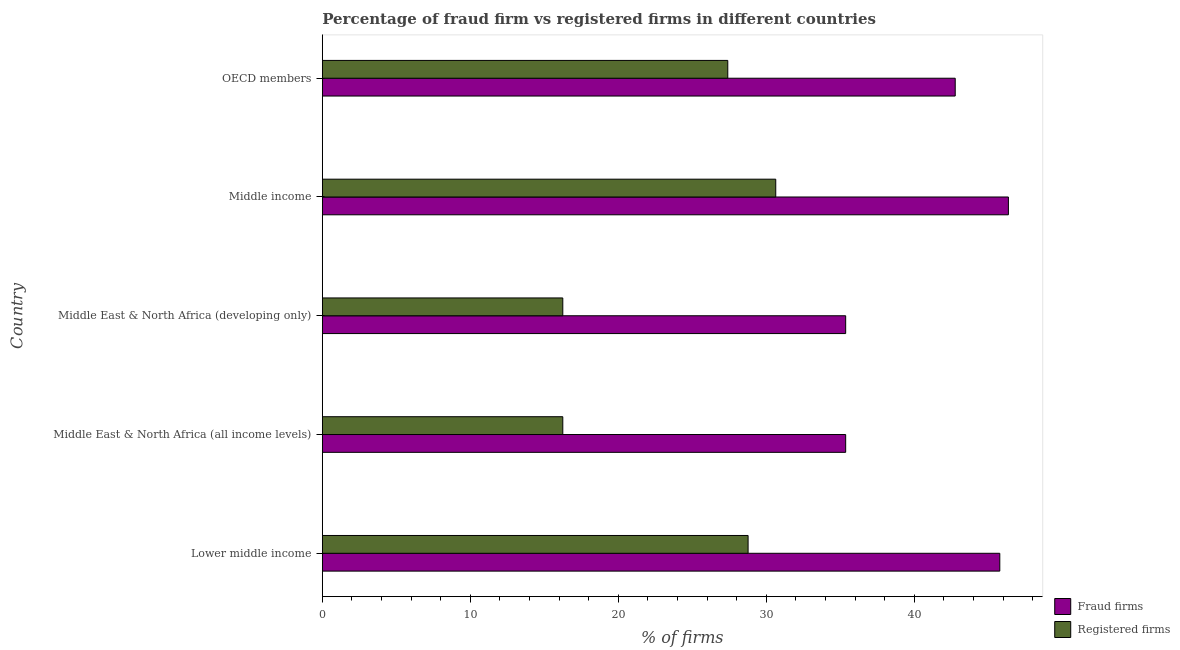How many different coloured bars are there?
Offer a terse response. 2. How many groups of bars are there?
Your answer should be very brief. 5. Are the number of bars per tick equal to the number of legend labels?
Offer a very short reply. Yes. Are the number of bars on each tick of the Y-axis equal?
Your answer should be very brief. Yes. How many bars are there on the 5th tick from the bottom?
Provide a succinct answer. 2. What is the label of the 5th group of bars from the top?
Ensure brevity in your answer.  Lower middle income. What is the percentage of registered firms in Middle income?
Ensure brevity in your answer.  30.64. Across all countries, what is the maximum percentage of registered firms?
Your answer should be compact. 30.64. Across all countries, what is the minimum percentage of fraud firms?
Your answer should be compact. 35.37. In which country was the percentage of registered firms minimum?
Make the answer very short. Middle East & North Africa (all income levels). What is the total percentage of fraud firms in the graph?
Give a very brief answer. 205.65. What is the difference between the percentage of fraud firms in Middle East & North Africa (all income levels) and that in OECD members?
Offer a terse response. -7.4. What is the difference between the percentage of registered firms in OECD members and the percentage of fraud firms in Middle East & North Africa (developing only)?
Ensure brevity in your answer.  -7.97. What is the average percentage of fraud firms per country?
Offer a terse response. 41.13. What is the difference between the percentage of fraud firms and percentage of registered firms in Middle East & North Africa (all income levels)?
Make the answer very short. 19.12. In how many countries, is the percentage of registered firms greater than 42 %?
Provide a succinct answer. 0. What is the ratio of the percentage of registered firms in Middle East & North Africa (all income levels) to that in Middle income?
Provide a succinct answer. 0.53. Is the percentage of fraud firms in Middle East & North Africa (developing only) less than that in OECD members?
Your response must be concise. Yes. Is the difference between the percentage of registered firms in Middle East & North Africa (developing only) and Middle income greater than the difference between the percentage of fraud firms in Middle East & North Africa (developing only) and Middle income?
Keep it short and to the point. No. What is the difference between the highest and the second highest percentage of registered firms?
Provide a short and direct response. 1.87. What is the difference between the highest and the lowest percentage of fraud firms?
Your answer should be very brief. 11. In how many countries, is the percentage of fraud firms greater than the average percentage of fraud firms taken over all countries?
Your response must be concise. 3. What does the 2nd bar from the top in Middle East & North Africa (all income levels) represents?
Make the answer very short. Fraud firms. What does the 2nd bar from the bottom in Middle income represents?
Make the answer very short. Registered firms. Are all the bars in the graph horizontal?
Your answer should be very brief. Yes. How many countries are there in the graph?
Your response must be concise. 5. Are the values on the major ticks of X-axis written in scientific E-notation?
Make the answer very short. No. Does the graph contain grids?
Your answer should be very brief. No. Where does the legend appear in the graph?
Your answer should be very brief. Bottom right. What is the title of the graph?
Offer a terse response. Percentage of fraud firm vs registered firms in different countries. What is the label or title of the X-axis?
Offer a very short reply. % of firms. What is the label or title of the Y-axis?
Your response must be concise. Country. What is the % of firms in Fraud firms in Lower middle income?
Your answer should be very brief. 45.78. What is the % of firms in Registered firms in Lower middle income?
Give a very brief answer. 28.77. What is the % of firms in Fraud firms in Middle East & North Africa (all income levels)?
Provide a short and direct response. 35.37. What is the % of firms of Registered firms in Middle East & North Africa (all income levels)?
Keep it short and to the point. 16.25. What is the % of firms in Fraud firms in Middle East & North Africa (developing only)?
Provide a succinct answer. 35.37. What is the % of firms of Registered firms in Middle East & North Africa (developing only)?
Offer a terse response. 16.25. What is the % of firms in Fraud firms in Middle income?
Provide a succinct answer. 46.36. What is the % of firms of Registered firms in Middle income?
Ensure brevity in your answer.  30.64. What is the % of firms in Fraud firms in OECD members?
Give a very brief answer. 42.77. What is the % of firms of Registered firms in OECD members?
Offer a very short reply. 27.4. Across all countries, what is the maximum % of firms of Fraud firms?
Give a very brief answer. 46.36. Across all countries, what is the maximum % of firms in Registered firms?
Offer a very short reply. 30.64. Across all countries, what is the minimum % of firms in Fraud firms?
Your answer should be compact. 35.37. Across all countries, what is the minimum % of firms of Registered firms?
Your response must be concise. 16.25. What is the total % of firms in Fraud firms in the graph?
Offer a very short reply. 205.65. What is the total % of firms of Registered firms in the graph?
Keep it short and to the point. 119.31. What is the difference between the % of firms in Fraud firms in Lower middle income and that in Middle East & North Africa (all income levels)?
Offer a very short reply. 10.42. What is the difference between the % of firms of Registered firms in Lower middle income and that in Middle East & North Africa (all income levels)?
Give a very brief answer. 12.52. What is the difference between the % of firms in Fraud firms in Lower middle income and that in Middle East & North Africa (developing only)?
Your response must be concise. 10.42. What is the difference between the % of firms in Registered firms in Lower middle income and that in Middle East & North Africa (developing only)?
Provide a short and direct response. 12.52. What is the difference between the % of firms in Fraud firms in Lower middle income and that in Middle income?
Ensure brevity in your answer.  -0.58. What is the difference between the % of firms of Registered firms in Lower middle income and that in Middle income?
Offer a very short reply. -1.87. What is the difference between the % of firms of Fraud firms in Lower middle income and that in OECD members?
Give a very brief answer. 3.01. What is the difference between the % of firms of Registered firms in Lower middle income and that in OECD members?
Your answer should be compact. 1.37. What is the difference between the % of firms in Registered firms in Middle East & North Africa (all income levels) and that in Middle East & North Africa (developing only)?
Your answer should be compact. 0. What is the difference between the % of firms in Fraud firms in Middle East & North Africa (all income levels) and that in Middle income?
Your answer should be compact. -11. What is the difference between the % of firms of Registered firms in Middle East & North Africa (all income levels) and that in Middle income?
Make the answer very short. -14.39. What is the difference between the % of firms of Fraud firms in Middle East & North Africa (all income levels) and that in OECD members?
Make the answer very short. -7.4. What is the difference between the % of firms in Registered firms in Middle East & North Africa (all income levels) and that in OECD members?
Keep it short and to the point. -11.15. What is the difference between the % of firms of Fraud firms in Middle East & North Africa (developing only) and that in Middle income?
Your response must be concise. -11. What is the difference between the % of firms in Registered firms in Middle East & North Africa (developing only) and that in Middle income?
Keep it short and to the point. -14.39. What is the difference between the % of firms in Fraud firms in Middle East & North Africa (developing only) and that in OECD members?
Offer a very short reply. -7.4. What is the difference between the % of firms in Registered firms in Middle East & North Africa (developing only) and that in OECD members?
Your answer should be very brief. -11.15. What is the difference between the % of firms of Fraud firms in Middle income and that in OECD members?
Give a very brief answer. 3.59. What is the difference between the % of firms of Registered firms in Middle income and that in OECD members?
Your answer should be very brief. 3.24. What is the difference between the % of firms in Fraud firms in Lower middle income and the % of firms in Registered firms in Middle East & North Africa (all income levels)?
Ensure brevity in your answer.  29.53. What is the difference between the % of firms of Fraud firms in Lower middle income and the % of firms of Registered firms in Middle East & North Africa (developing only)?
Your answer should be very brief. 29.53. What is the difference between the % of firms in Fraud firms in Lower middle income and the % of firms in Registered firms in Middle income?
Keep it short and to the point. 15.14. What is the difference between the % of firms of Fraud firms in Lower middle income and the % of firms of Registered firms in OECD members?
Provide a succinct answer. 18.38. What is the difference between the % of firms of Fraud firms in Middle East & North Africa (all income levels) and the % of firms of Registered firms in Middle East & North Africa (developing only)?
Your response must be concise. 19.12. What is the difference between the % of firms of Fraud firms in Middle East & North Africa (all income levels) and the % of firms of Registered firms in Middle income?
Provide a short and direct response. 4.73. What is the difference between the % of firms in Fraud firms in Middle East & North Africa (all income levels) and the % of firms in Registered firms in OECD members?
Give a very brief answer. 7.97. What is the difference between the % of firms of Fraud firms in Middle East & North Africa (developing only) and the % of firms of Registered firms in Middle income?
Offer a terse response. 4.73. What is the difference between the % of firms in Fraud firms in Middle East & North Africa (developing only) and the % of firms in Registered firms in OECD members?
Ensure brevity in your answer.  7.97. What is the difference between the % of firms in Fraud firms in Middle income and the % of firms in Registered firms in OECD members?
Keep it short and to the point. 18.96. What is the average % of firms of Fraud firms per country?
Keep it short and to the point. 41.13. What is the average % of firms in Registered firms per country?
Make the answer very short. 23.86. What is the difference between the % of firms in Fraud firms and % of firms in Registered firms in Lower middle income?
Your answer should be very brief. 17.01. What is the difference between the % of firms of Fraud firms and % of firms of Registered firms in Middle East & North Africa (all income levels)?
Provide a succinct answer. 19.12. What is the difference between the % of firms of Fraud firms and % of firms of Registered firms in Middle East & North Africa (developing only)?
Your response must be concise. 19.12. What is the difference between the % of firms of Fraud firms and % of firms of Registered firms in Middle income?
Your answer should be compact. 15.72. What is the difference between the % of firms in Fraud firms and % of firms in Registered firms in OECD members?
Keep it short and to the point. 15.37. What is the ratio of the % of firms in Fraud firms in Lower middle income to that in Middle East & North Africa (all income levels)?
Provide a short and direct response. 1.29. What is the ratio of the % of firms in Registered firms in Lower middle income to that in Middle East & North Africa (all income levels)?
Make the answer very short. 1.77. What is the ratio of the % of firms of Fraud firms in Lower middle income to that in Middle East & North Africa (developing only)?
Your answer should be compact. 1.29. What is the ratio of the % of firms of Registered firms in Lower middle income to that in Middle East & North Africa (developing only)?
Keep it short and to the point. 1.77. What is the ratio of the % of firms in Fraud firms in Lower middle income to that in Middle income?
Provide a succinct answer. 0.99. What is the ratio of the % of firms of Registered firms in Lower middle income to that in Middle income?
Ensure brevity in your answer.  0.94. What is the ratio of the % of firms of Fraud firms in Lower middle income to that in OECD members?
Your answer should be very brief. 1.07. What is the ratio of the % of firms in Registered firms in Lower middle income to that in OECD members?
Your answer should be compact. 1.05. What is the ratio of the % of firms of Fraud firms in Middle East & North Africa (all income levels) to that in Middle income?
Make the answer very short. 0.76. What is the ratio of the % of firms of Registered firms in Middle East & North Africa (all income levels) to that in Middle income?
Give a very brief answer. 0.53. What is the ratio of the % of firms of Fraud firms in Middle East & North Africa (all income levels) to that in OECD members?
Ensure brevity in your answer.  0.83. What is the ratio of the % of firms in Registered firms in Middle East & North Africa (all income levels) to that in OECD members?
Give a very brief answer. 0.59. What is the ratio of the % of firms of Fraud firms in Middle East & North Africa (developing only) to that in Middle income?
Ensure brevity in your answer.  0.76. What is the ratio of the % of firms in Registered firms in Middle East & North Africa (developing only) to that in Middle income?
Ensure brevity in your answer.  0.53. What is the ratio of the % of firms of Fraud firms in Middle East & North Africa (developing only) to that in OECD members?
Provide a succinct answer. 0.83. What is the ratio of the % of firms of Registered firms in Middle East & North Africa (developing only) to that in OECD members?
Make the answer very short. 0.59. What is the ratio of the % of firms in Fraud firms in Middle income to that in OECD members?
Offer a very short reply. 1.08. What is the ratio of the % of firms of Registered firms in Middle income to that in OECD members?
Provide a short and direct response. 1.12. What is the difference between the highest and the second highest % of firms in Fraud firms?
Provide a succinct answer. 0.58. What is the difference between the highest and the second highest % of firms of Registered firms?
Offer a very short reply. 1.87. What is the difference between the highest and the lowest % of firms in Fraud firms?
Your answer should be very brief. 11. What is the difference between the highest and the lowest % of firms in Registered firms?
Your answer should be very brief. 14.39. 